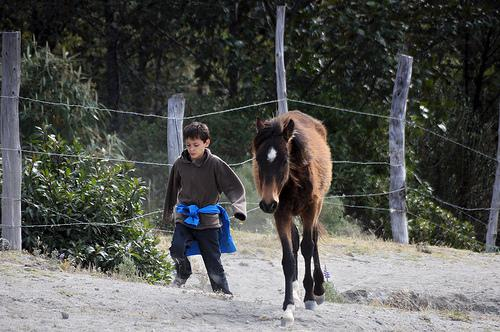Question: what color fur is in the middle of the horse's forehead?
Choices:
A. White.
B. Brown.
C. Yellow.
D. Black.
Answer with the letter. Answer: A Question: what is on the ground?
Choices:
A. Grass.
B. Raccoons.
C. Dirt.
D. Cans.
Answer with the letter. Answer: C Question: what is running along the boy's right side?
Choices:
A. Fence.
B. A horse.
C. A wall.
D. A dog.
Answer with the letter. Answer: A 